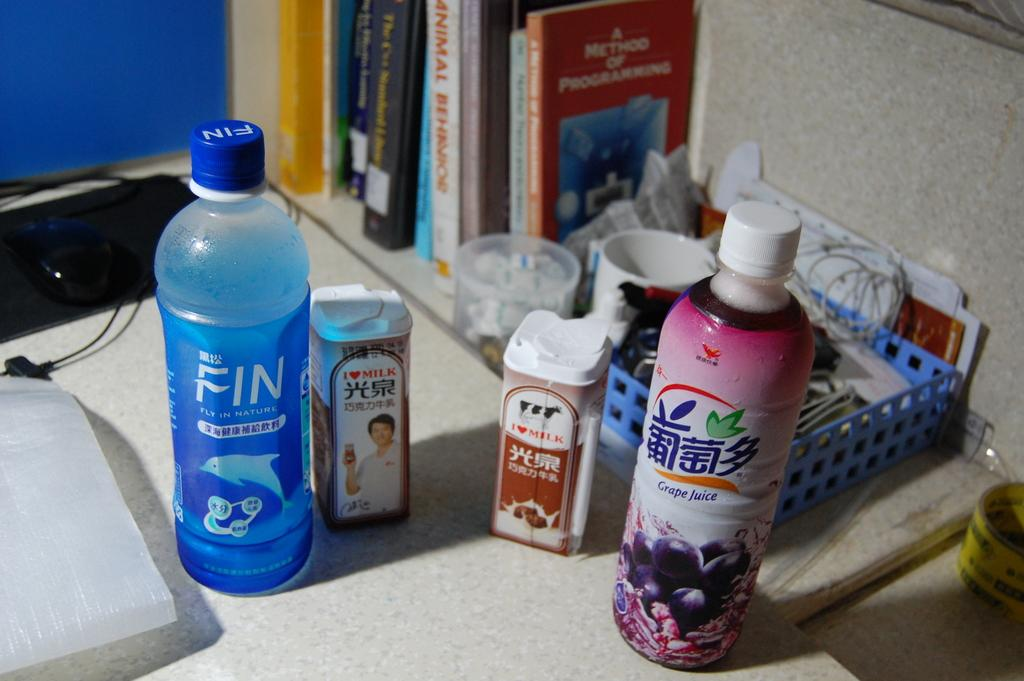<image>
Create a compact narrative representing the image presented. Bottle of grape juice next to a blue bottle of water. 